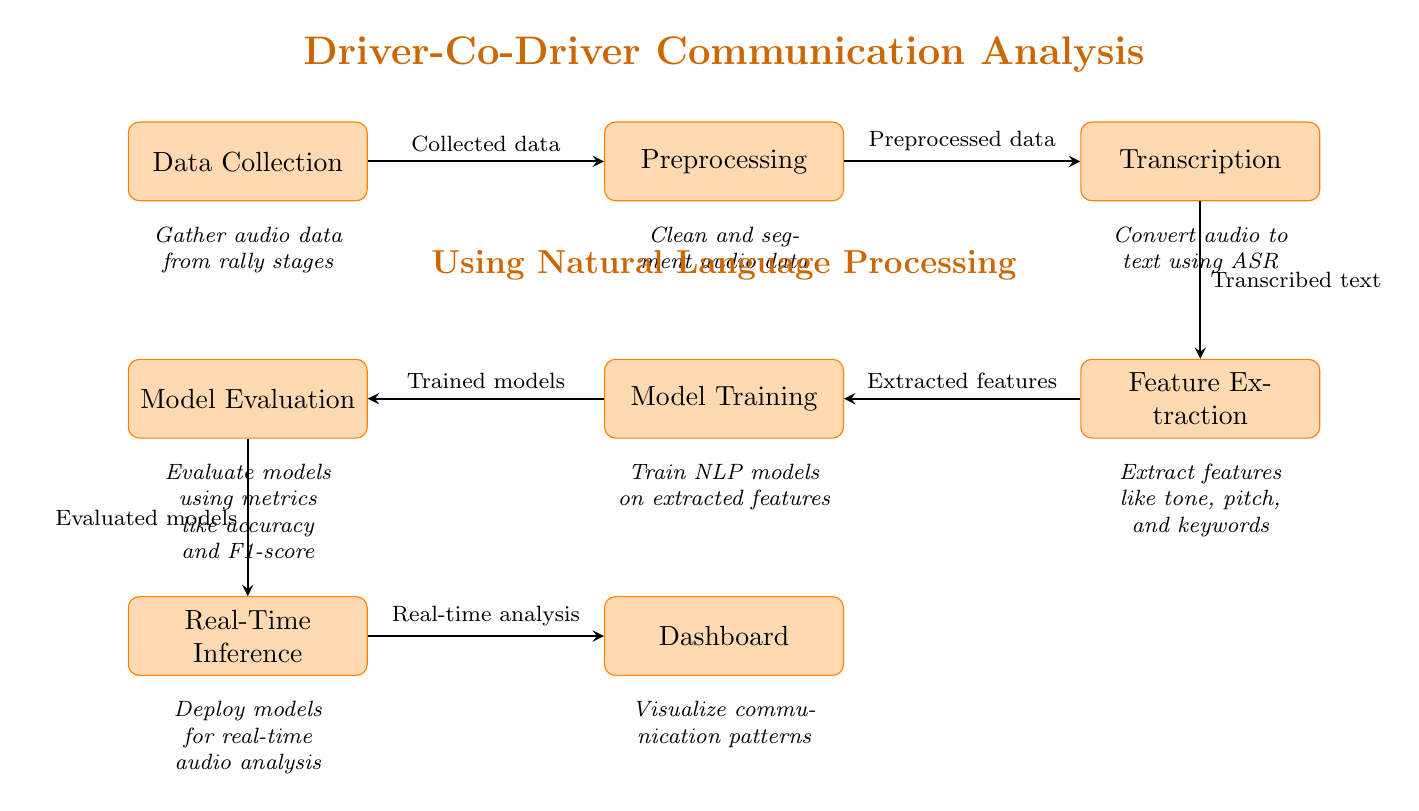What is the first process in the diagram? The first process in the diagram is labeled "Data Collection," which is the initial step in the workflow.
Answer: Data Collection How many processes are shown in the diagram? There are a total of seven processes illustrated in the diagram, as counted from the nodes provided.
Answer: Seven What kind of data is used in the transcription process? The transcription process utilizes "Transcribed text," which is the output from the previous node producing audio-to-text conversions.
Answer: Transcribed text What follows after feature extraction in the workflow? After feature extraction, the next process in the workflow is "Model Training," which takes the features derived from communication for the training of models.
Answer: Model Training What type of analysis does the dashboard provide? The dashboard provides "Real-time analysis," which visualizes the patterns derived from the communication data processed in the earlier stages.
Answer: Real-time analysis Which process involves evaluating models? The process that involves evaluating models is "Model Evaluation," which assesses the effectiveness of the trained models against various metrics.
Answer: Model Evaluation What is extracted during the feature extraction process? During the feature extraction process, features such as "tone, pitch, and keywords" are extracted, which represent essential characteristics of the communication.
Answer: Tone, pitch, and keywords How is audio data transformed before model training? Audio data is transformed into "Transcribed text" using the transcription process, which denotes the conversion from audio format to textual format.
Answer: Transcribed text What is the immediate output of the model training? The immediate output of the model training process is "Trained models," which are the models prepared to be evaluated afterward in the workflow.
Answer: Trained models 